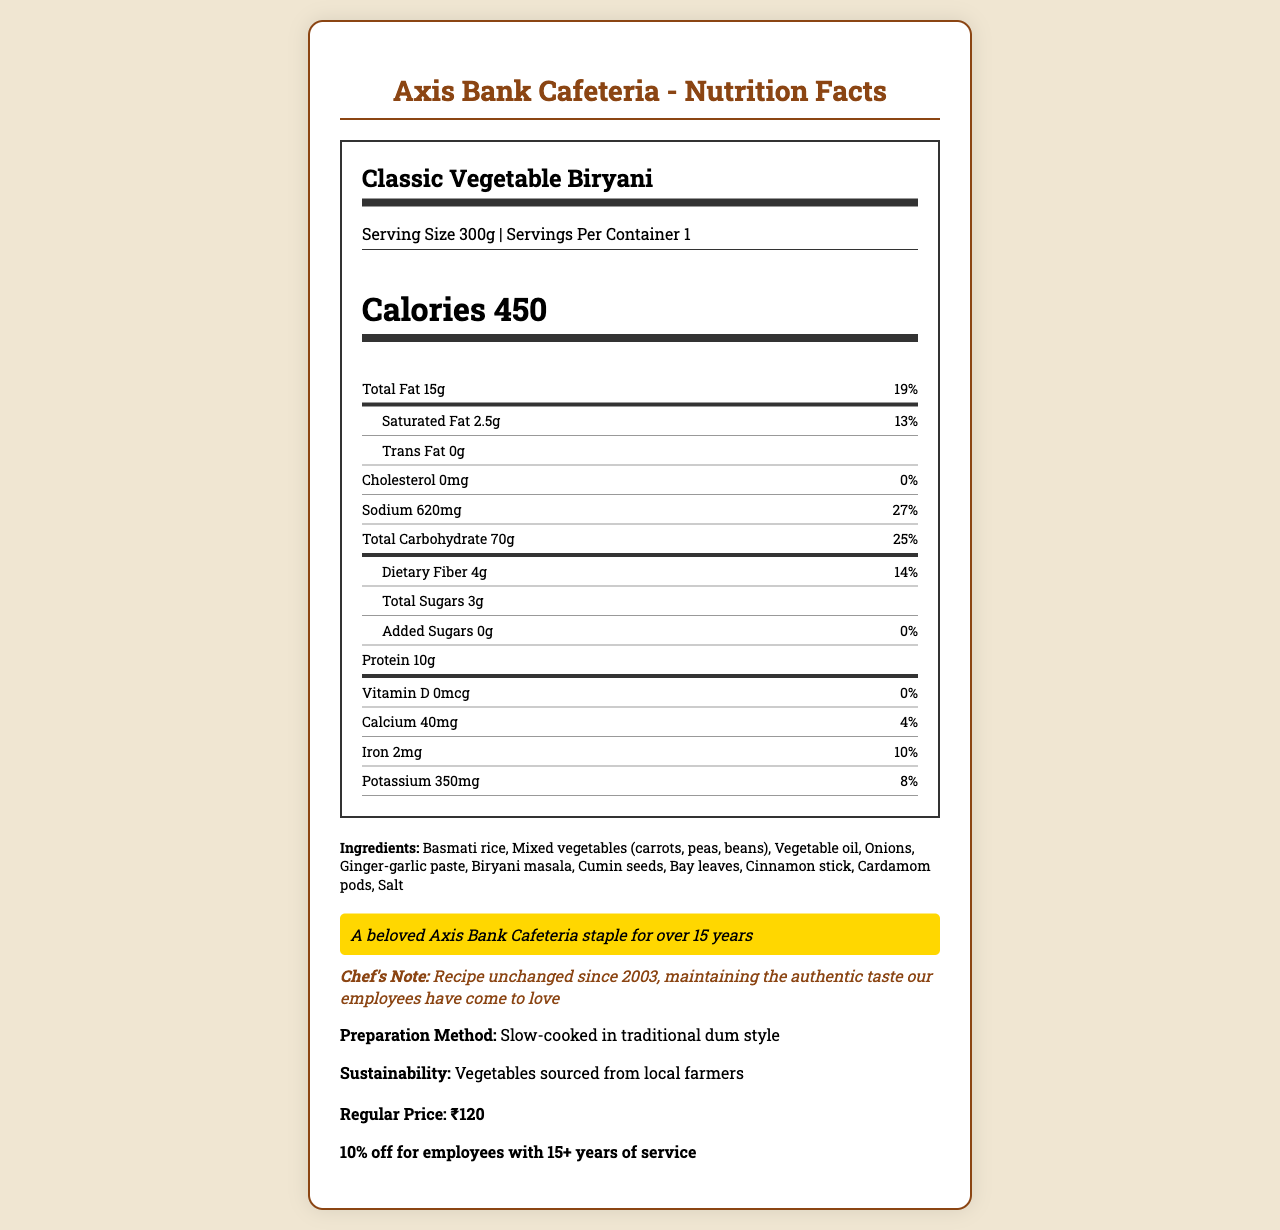what is the serving size of the Classic Vegetable Biryani? The serving size is clearly stated on the nutrition label as "Serving Size 300g."
Answer: 300g how many grams of total fat are in one serving? The nutrition label indicates there are "Total Fat 15g" per serving.
Answer: 15g what is the price of the Classic Vegetable Biryani after the senior employee discount? The document states the regular price is ₹120 and senior employees with 15+ years of service get a 10% discount. Therefore, ₹120 - (₹120 * 0.10) = ₹108.
Answer: ₹108 how much sodium is in each serving? The nutrition label lists "Sodium 620mg" in each serving.
Answer: 620mg what is the iron content per serving? The nutrition label mentions "Iron 2mg" for each serving.
Answer: 2mg what percentage of the daily recommended intake of saturated fat does one serving provide? The nutrition label specifies the saturated fat amount as "2.5g" and indicates this as "13%" of the daily value.
Answer: 13% which ingredients are included in the Classic Vegetable Biryani? A. Basmati rice, Mixed vegetables, Fish B. Basmati rice, Mixed vegetables, Biryani masala C. Basmati rice, Mixed vegetables, Chicken The ingredients listed are "Basmati rice, Mixed vegetables (carrots, peas, beans), Vegetable oil, Onions, Ginger-garlic paste, Biryani masala, Cumin seeds, Bay leaves, Cinnamon stick, Cardamom pods, Salt."
Answer: B what is the main nutrition claim highlight of this menu item? A. Low Fat B. High Protein C. Axis Bank Cafeteria staple for over 15 years The highlight states "A beloved Axis Bank Cafeteria staple for over 15 years."
Answer: C does Classic Vegetable Biryani contain any added sugars? The nutrition label shows "Added Sugars 0g," meaning there are no added sugars.
Answer: No how has the recipe of the Classic Vegetable Biryani changed over time according to the document? The chef's note clarifies that the recipe has been unchanged since 2003.
Answer: It has not changed since 2003 what percentage of the daily recommended carbohydrate intake does one serving provide? The nutrition label indicates "Total Carbohydrate 70g" and states this is "25%" of the daily value.
Answer: 25% is there any allergen information provided for this menu item? The document lists allergens as "None."
Answer: Yes, None what is the preparation method for this dish? The document specifies the preparation method as "Slow-cooked in traditional dum style."
Answer: Slow-cooked in traditional dum style summarize the main idea of the document. The document is an extensive description of a menu item from Axis Bank Cafeteria, including various nutritional facts, preparation details, and emphasizes its stability over the years and its popularity among employees.
Answer: The document provides a detailed nutrition label for the Classic Vegetable Biryani served at Axis Bank Cafeteria, highlighting its ingredients, preparation method, and nutritional information. It also mentions that it is a long-standing employee favorite with a recipe unchanged since 2003. does the Classic Vegetable Biryani contain trans fat? The nutrition label lists "Trans Fat 0g," indicating it does not contain trans fat.
Answer: No how many grams of protein are in one serving? The nutrition label states there are "Protein 10g" per serving.
Answer: 10g how much dietary fiber does one serving contain? The nutrition label shows "Dietary Fiber 4g" per serving.
Answer: 4g how many vitamins are detailed in the nutrition label of the Classic Vegetable Biryani? The nutrition label includes "Vitamin D" as an item but does not detail other vitamins like Vitamin C or E.
Answer: 1 (Vitamin D) is the vegetable biryani indicated as an employee favorite? The document mentions "employeeFavorite: true," meaning it is indicated as an employee favorite.
Answer: Yes what percentage of the daily calcium intake does this dish provide? The nutrition label specifies that the dish provides "Calcium 4%" of the daily value.
Answer: 4% what is the purpose of including sustainability information such as "Vegetables sourced from local farmers"? The document does not provide specific details on why the sustainability information is included.
Answer: Cannot be determined how does the regular price compare to other items on the menu? The document does not provide prices for other menu items, so a comparison cannot be made.
Answer: Not enough information 